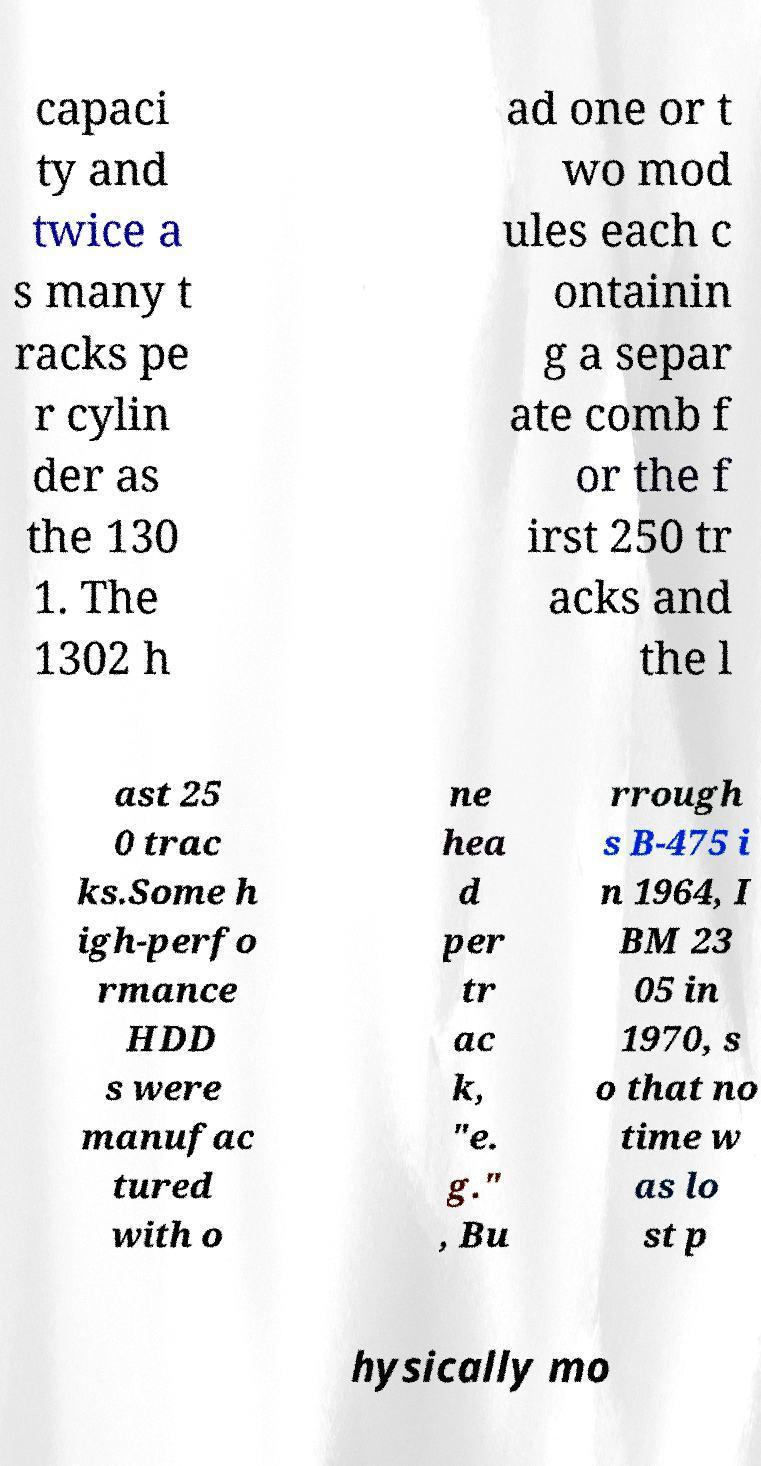What messages or text are displayed in this image? I need them in a readable, typed format. capaci ty and twice a s many t racks pe r cylin der as the 130 1. The 1302 h ad one or t wo mod ules each c ontainin g a separ ate comb f or the f irst 250 tr acks and the l ast 25 0 trac ks.Some h igh-perfo rmance HDD s were manufac tured with o ne hea d per tr ac k, "e. g." , Bu rrough s B-475 i n 1964, I BM 23 05 in 1970, s o that no time w as lo st p hysically mo 